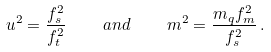Convert formula to latex. <formula><loc_0><loc_0><loc_500><loc_500>u ^ { 2 } = { \frac { f _ { s } ^ { 2 } } { f _ { t } ^ { 2 } } } \quad a n d \quad m ^ { 2 } = { \frac { m _ { q } f _ { m } ^ { 2 } } { f _ { s } ^ { 2 } } } \, .</formula> 